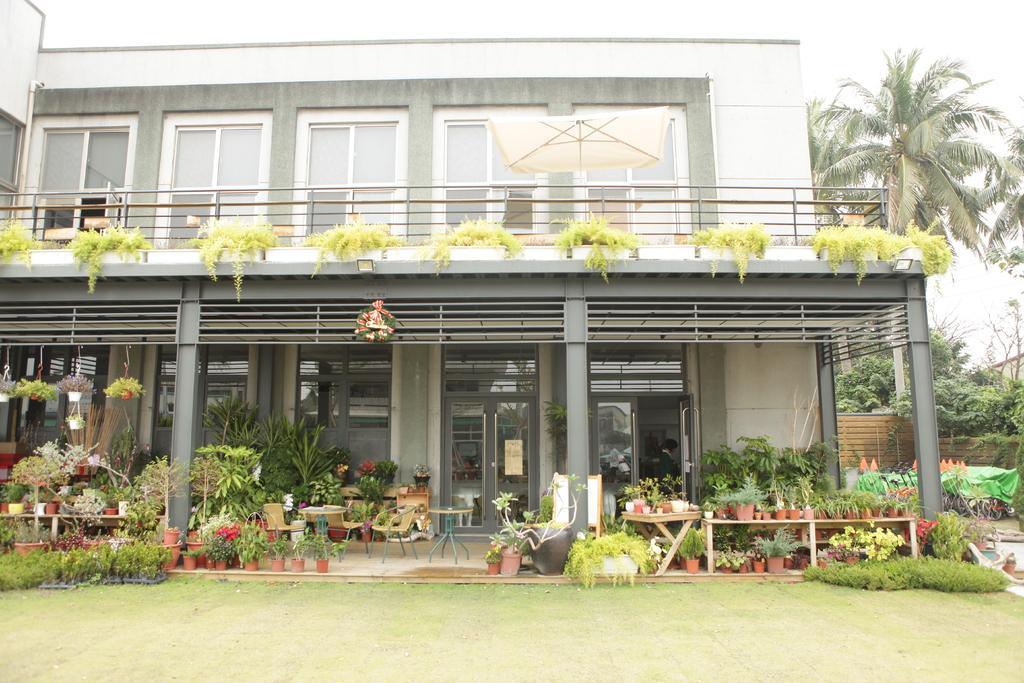Please provide a concise description of this image. In this picture we can see a building,trees,here we can see tables,chairs and house plants. 